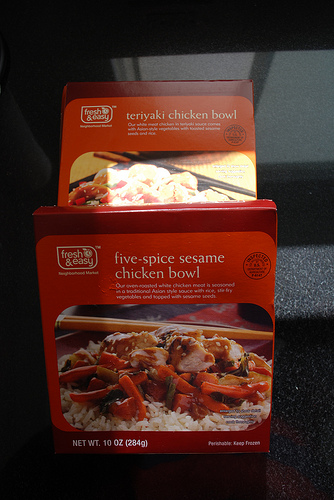<image>
Can you confirm if the box is next to the other box? Yes. The box is positioned adjacent to the other box, located nearby in the same general area. Is the chicken meal to the left of the teriyaki chicken? No. The chicken meal is not to the left of the teriyaki chicken. From this viewpoint, they have a different horizontal relationship. 